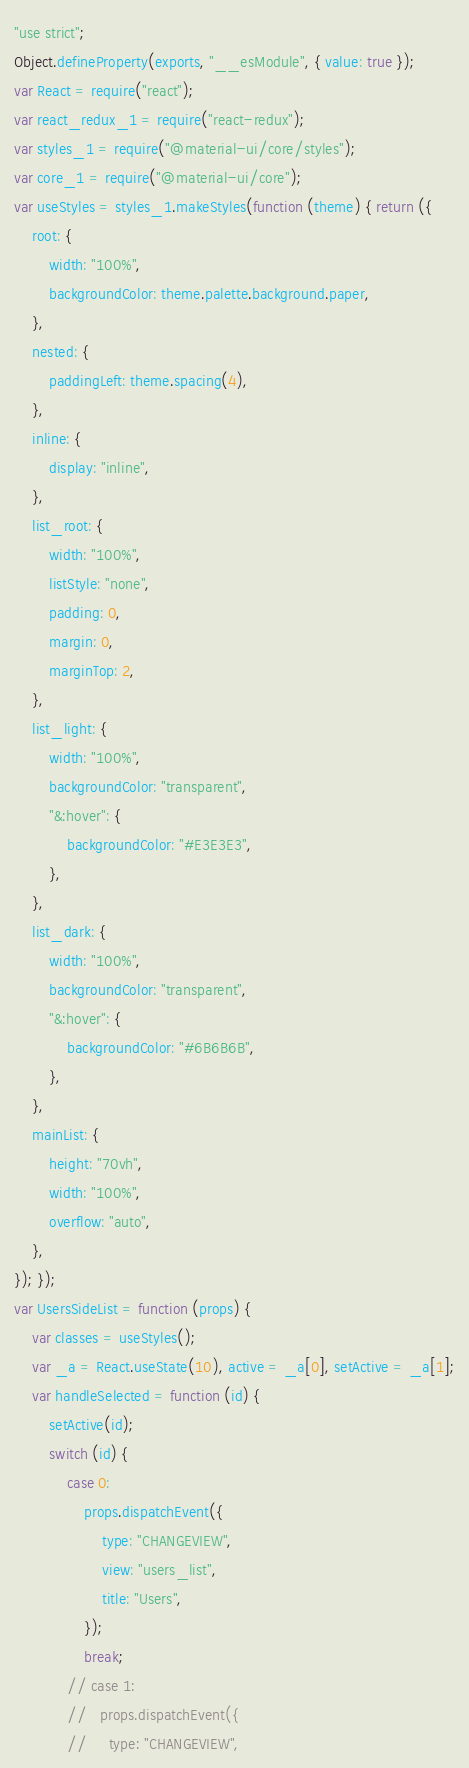Convert code to text. <code><loc_0><loc_0><loc_500><loc_500><_JavaScript_>"use strict";
Object.defineProperty(exports, "__esModule", { value: true });
var React = require("react");
var react_redux_1 = require("react-redux");
var styles_1 = require("@material-ui/core/styles");
var core_1 = require("@material-ui/core");
var useStyles = styles_1.makeStyles(function (theme) { return ({
    root: {
        width: "100%",
        backgroundColor: theme.palette.background.paper,
    },
    nested: {
        paddingLeft: theme.spacing(4),
    },
    inline: {
        display: "inline",
    },
    list_root: {
        width: "100%",
        listStyle: "none",
        padding: 0,
        margin: 0,
        marginTop: 2,
    },
    list_light: {
        width: "100%",
        backgroundColor: "transparent",
        "&:hover": {
            backgroundColor: "#E3E3E3",
        },
    },
    list_dark: {
        width: "100%",
        backgroundColor: "transparent",
        "&:hover": {
            backgroundColor: "#6B6B6B",
        },
    },
    mainList: {
        height: "70vh",
        width: "100%",
        overflow: "auto",
    },
}); });
var UsersSideList = function (props) {
    var classes = useStyles();
    var _a = React.useState(10), active = _a[0], setActive = _a[1];
    var handleSelected = function (id) {
        setActive(id);
        switch (id) {
            case 0:
                props.dispatchEvent({
                    type: "CHANGEVIEW",
                    view: "users_list",
                    title: "Users",
                });
                break;
            // case 1:
            //   props.dispatchEvent({
            //     type: "CHANGEVIEW",</code> 